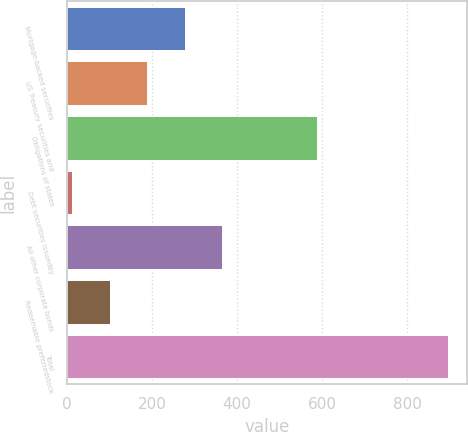Convert chart. <chart><loc_0><loc_0><loc_500><loc_500><bar_chart><fcel>Mortgage-backed securities<fcel>US Treasury securities and<fcel>Obligations of states<fcel>Debt securities issuedby<fcel>All other corporate bonds<fcel>Redeemable preferredstock<fcel>Total<nl><fcel>276.8<fcel>188.2<fcel>587<fcel>11<fcel>365.4<fcel>99.6<fcel>897<nl></chart> 